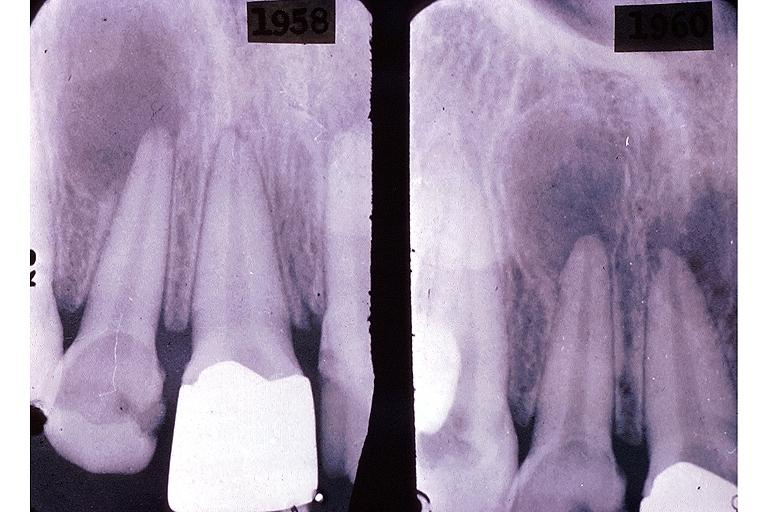what is present?
Answer the question using a single word or phrase. Oral 